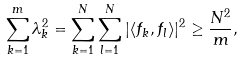<formula> <loc_0><loc_0><loc_500><loc_500>\sum _ { k = 1 } ^ { m } \lambda _ { k } ^ { 2 } = \sum _ { k = 1 } ^ { N } \sum _ { l = 1 } ^ { N } | \langle f _ { k } , f _ { l } \rangle | ^ { 2 } \geq \frac { N ^ { 2 } } { m } ,</formula> 